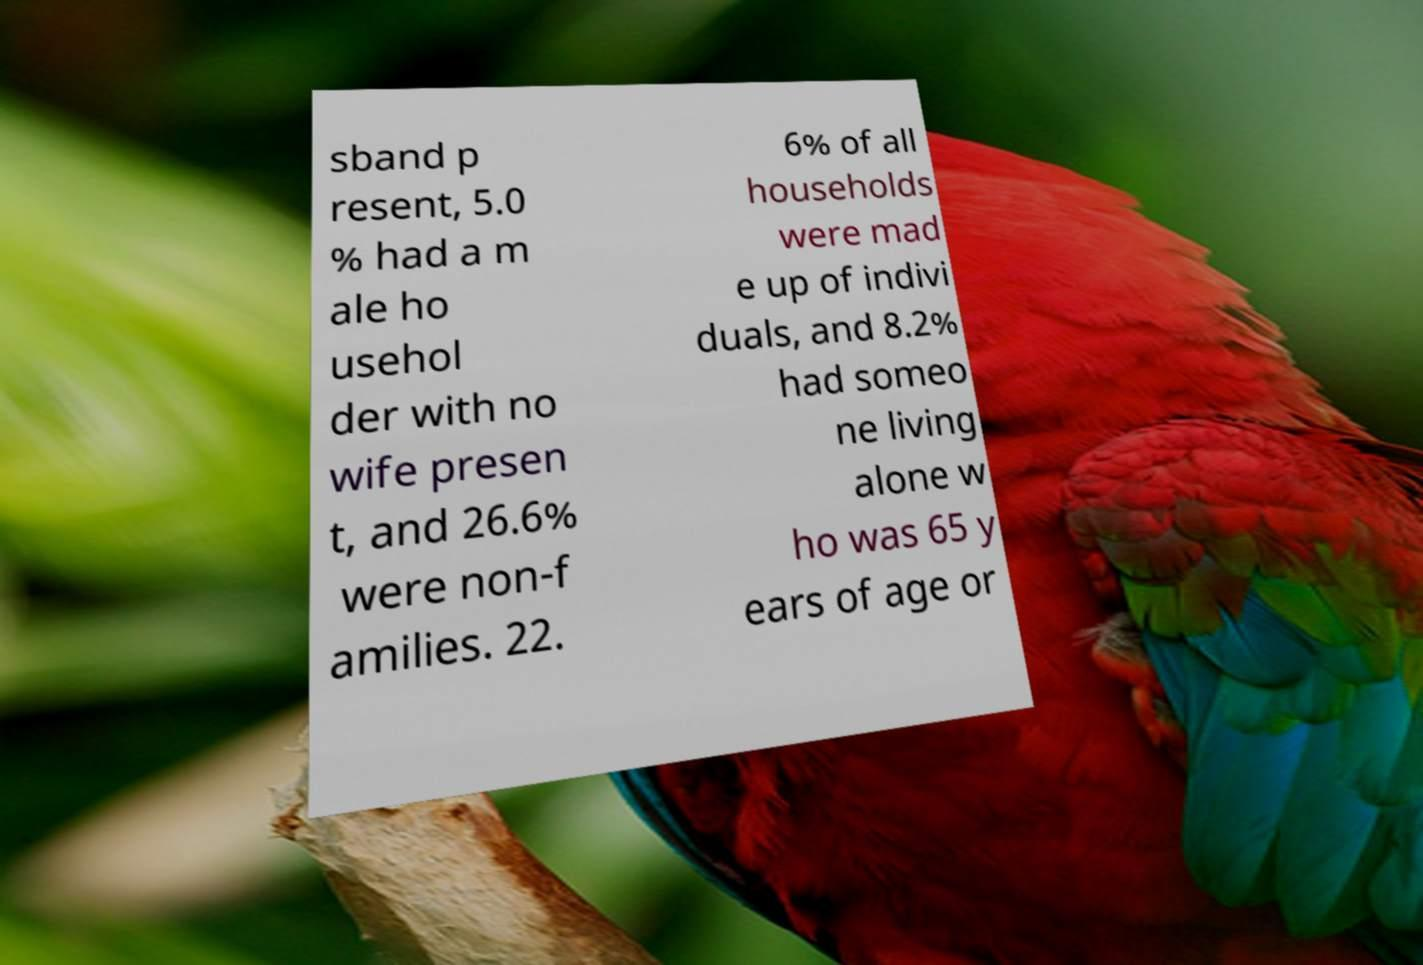For documentation purposes, I need the text within this image transcribed. Could you provide that? sband p resent, 5.0 % had a m ale ho usehol der with no wife presen t, and 26.6% were non-f amilies. 22. 6% of all households were mad e up of indivi duals, and 8.2% had someo ne living alone w ho was 65 y ears of age or 